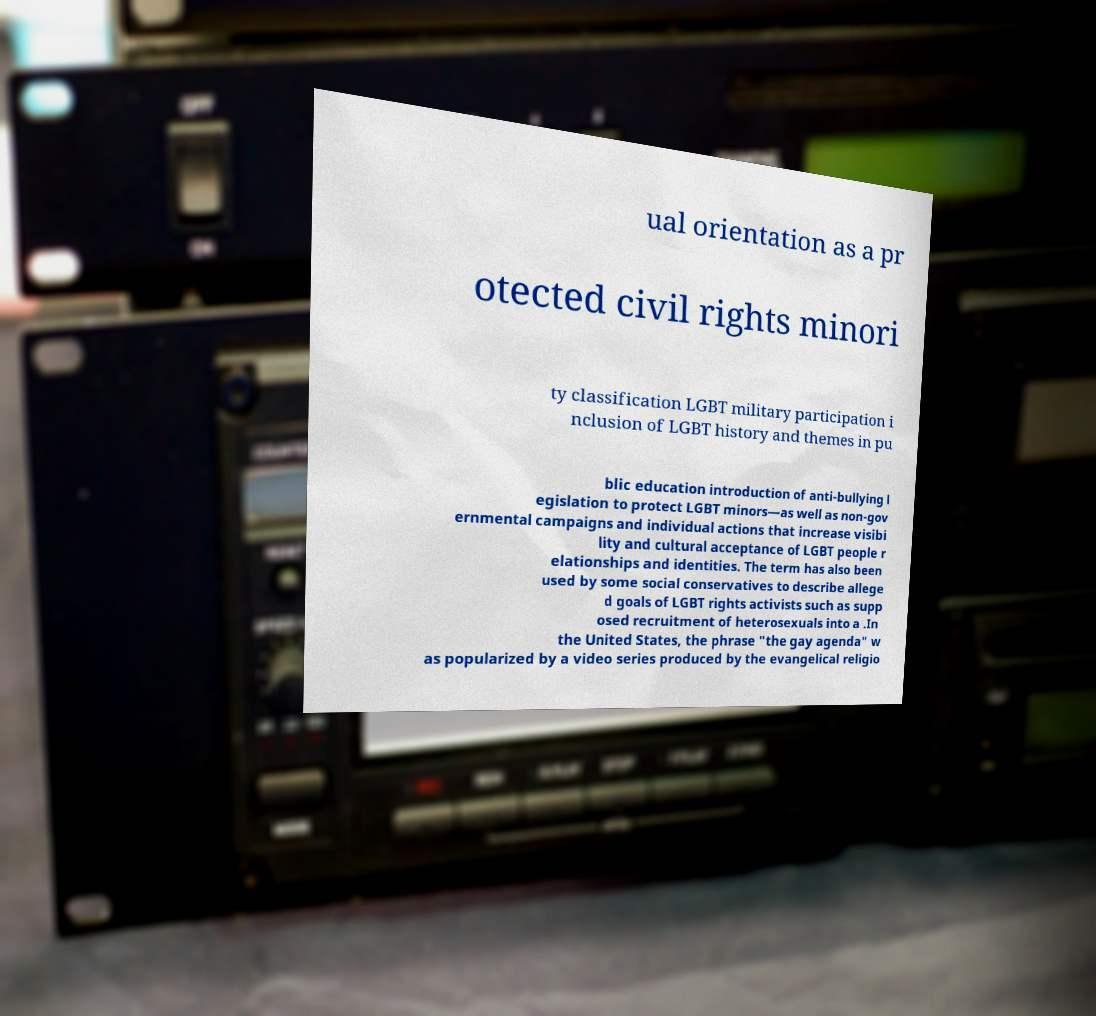Can you read and provide the text displayed in the image?This photo seems to have some interesting text. Can you extract and type it out for me? ual orientation as a pr otected civil rights minori ty classification LGBT military participation i nclusion of LGBT history and themes in pu blic education introduction of anti-bullying l egislation to protect LGBT minors—as well as non-gov ernmental campaigns and individual actions that increase visibi lity and cultural acceptance of LGBT people r elationships and identities. The term has also been used by some social conservatives to describe allege d goals of LGBT rights activists such as supp osed recruitment of heterosexuals into a .In the United States, the phrase "the gay agenda" w as popularized by a video series produced by the evangelical religio 